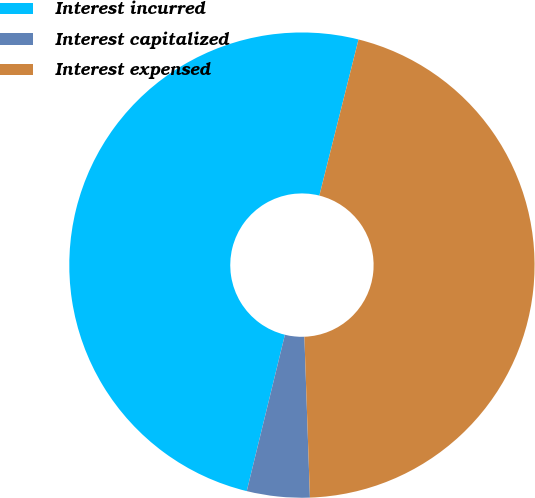<chart> <loc_0><loc_0><loc_500><loc_500><pie_chart><fcel>Interest incurred<fcel>Interest capitalized<fcel>Interest expensed<nl><fcel>50.1%<fcel>4.36%<fcel>45.54%<nl></chart> 